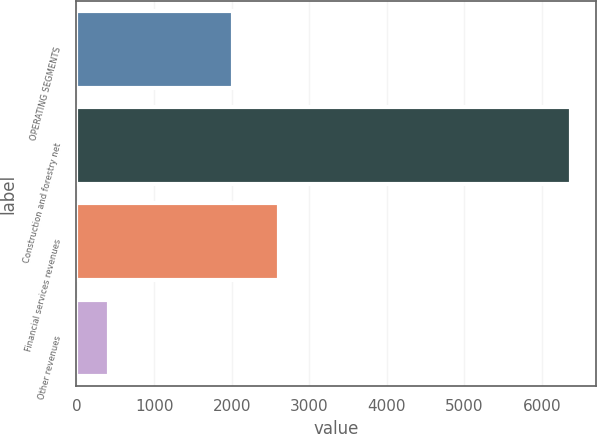Convert chart to OTSL. <chart><loc_0><loc_0><loc_500><loc_500><bar_chart><fcel>OPERATING SEGMENTS<fcel>Construction and forestry net<fcel>Financial services revenues<fcel>Other revenues<nl><fcel>2012<fcel>6378<fcel>2607.7<fcel>421<nl></chart> 